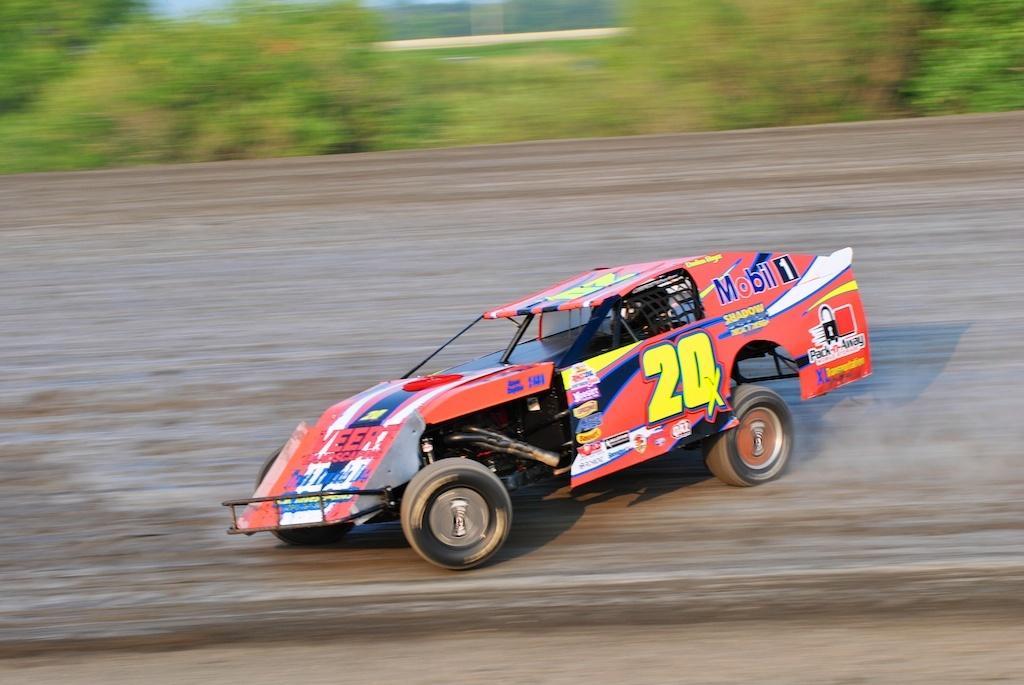How would you summarize this image in a sentence or two? In this image I can see a car which is orange, blue, yellow and white in color is on the road. I can see the blurry background in which I can see few trees and few other objects. 